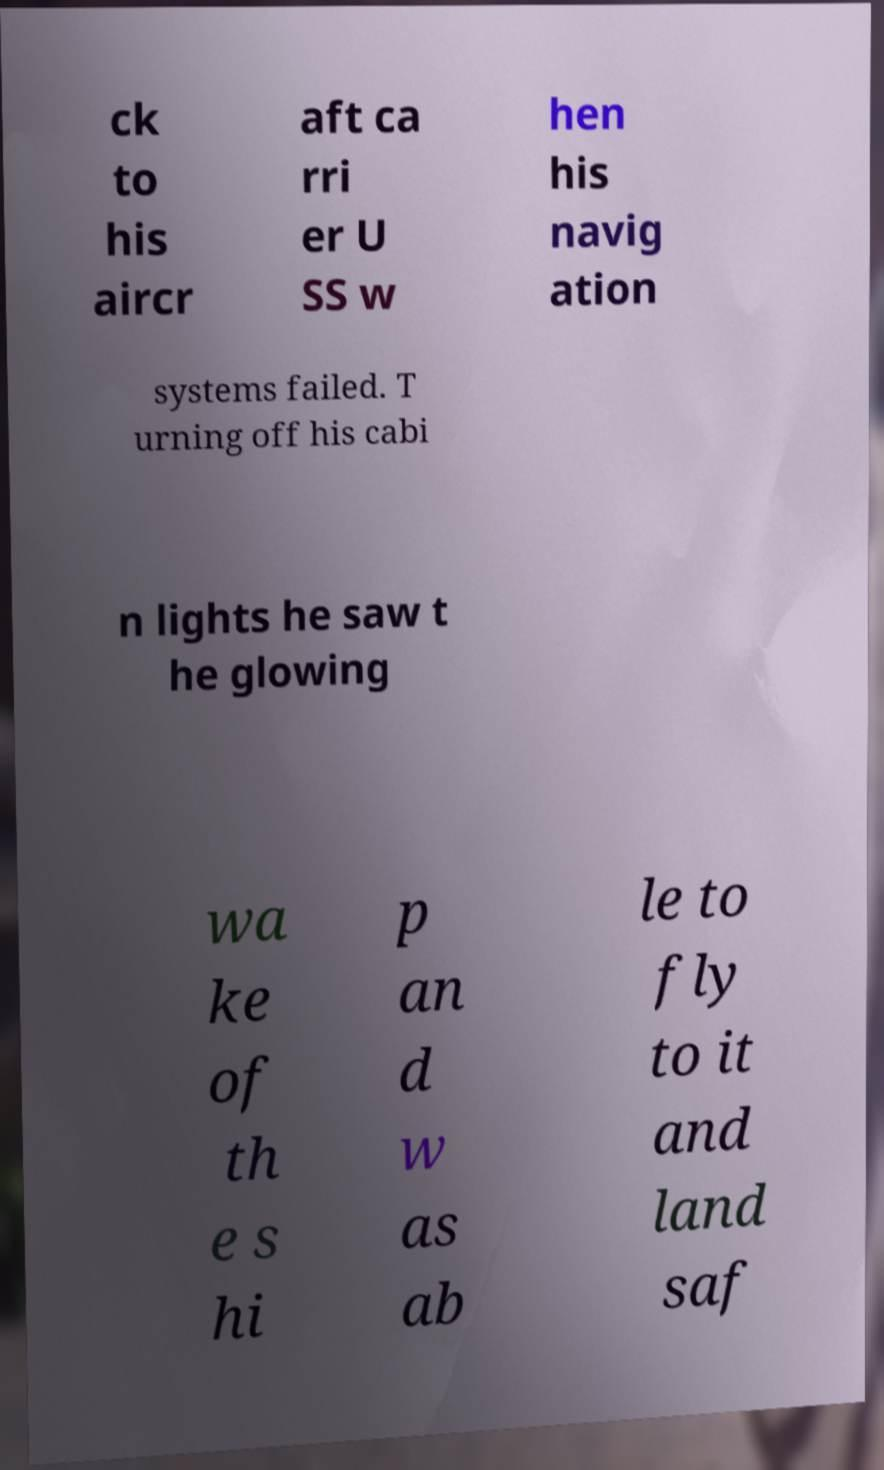Please identify and transcribe the text found in this image. ck to his aircr aft ca rri er U SS w hen his navig ation systems failed. T urning off his cabi n lights he saw t he glowing wa ke of th e s hi p an d w as ab le to fly to it and land saf 